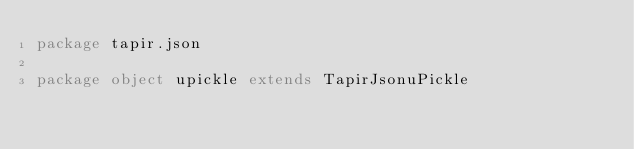Convert code to text. <code><loc_0><loc_0><loc_500><loc_500><_Scala_>package tapir.json

package object upickle extends TapirJsonuPickle
</code> 